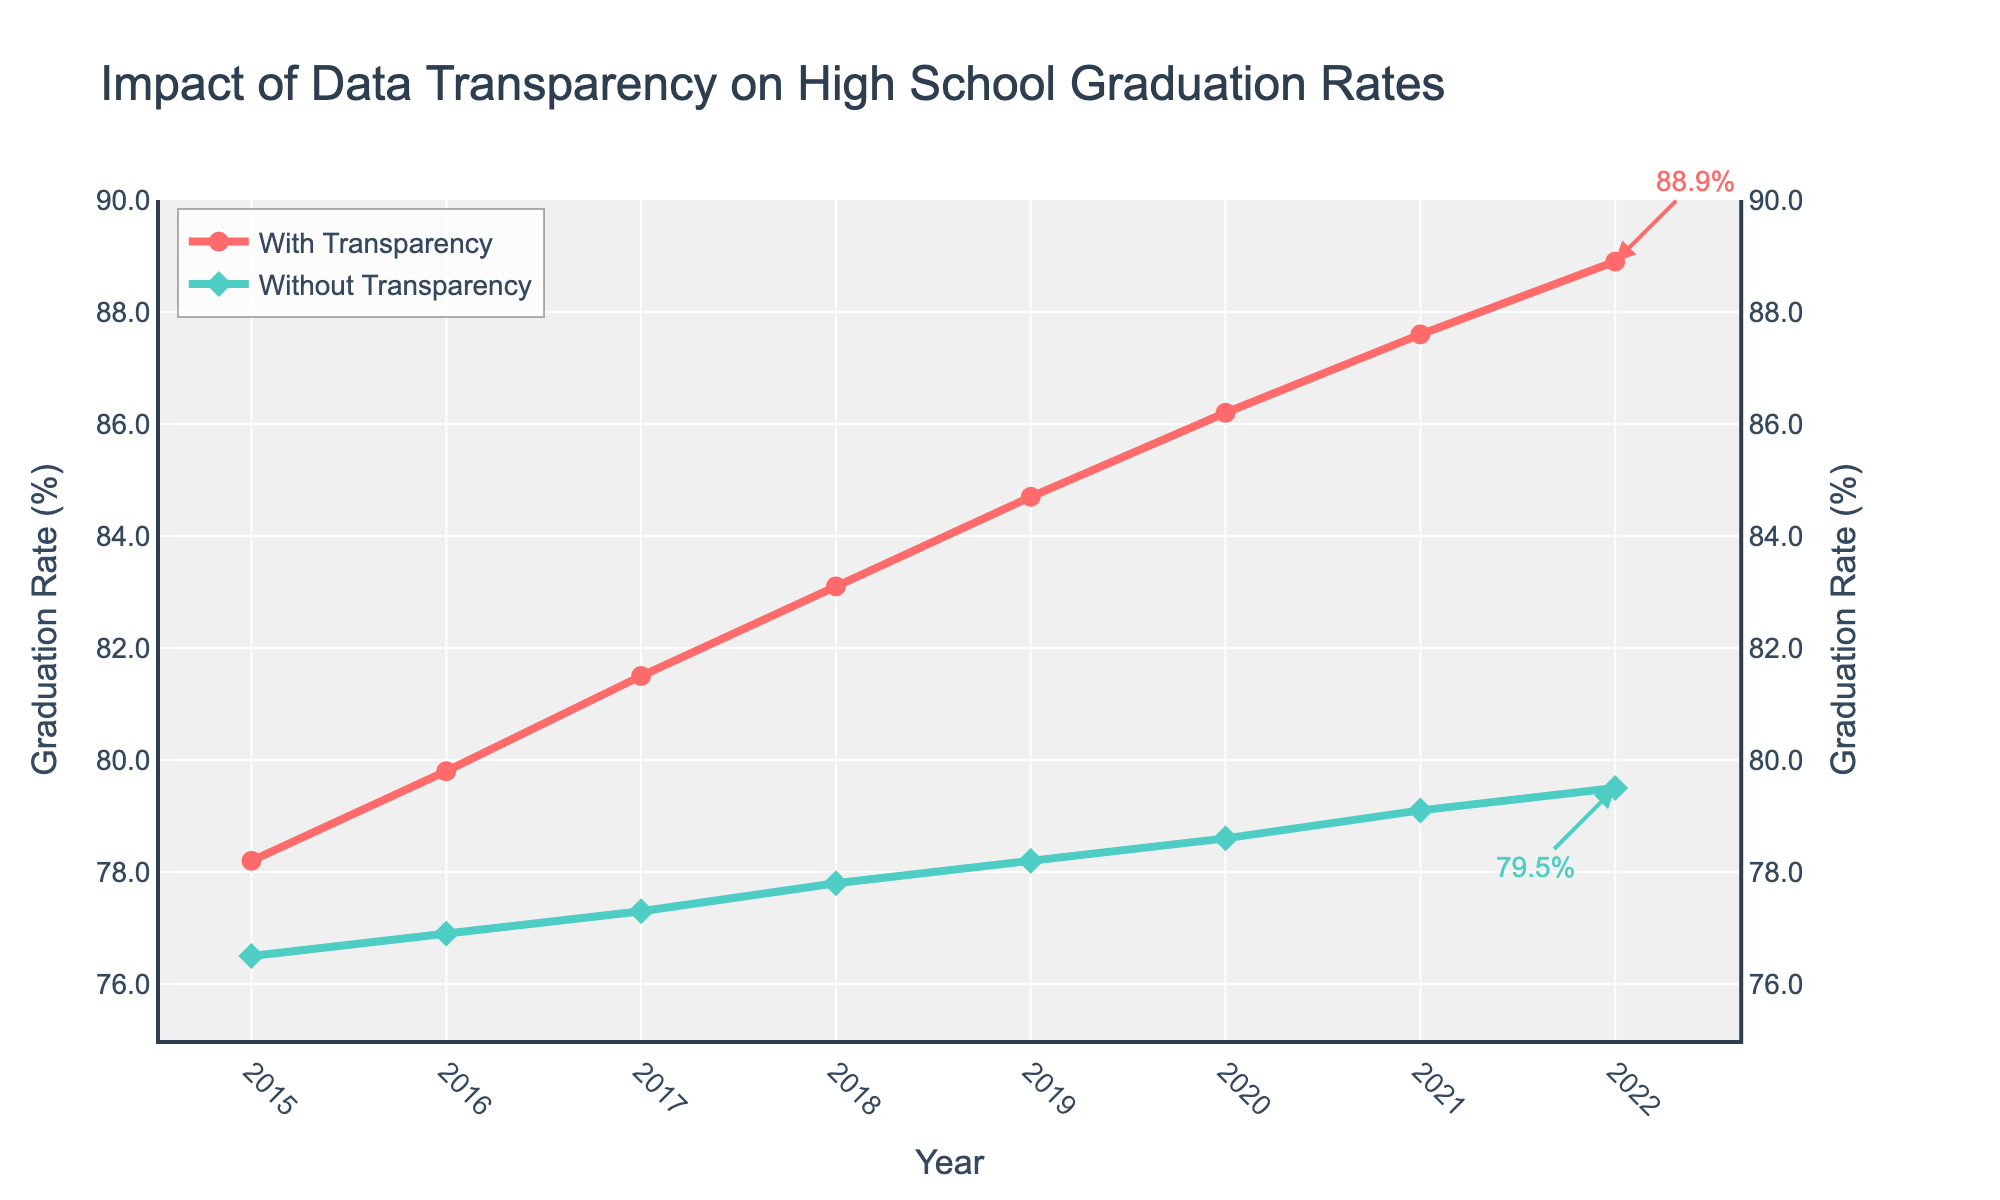What is the graduation rate for schools with transparency initiatives in 2020? The plot shows the graduation rates for each year. Looking at the line for "With Transparency" in 2020, the graduation rate is indicated by the point on the graph.
Answer: 86.2% How much did the graduation rate for schools with transparency initiatives increase from 2015 to 2022? First, find the rates for both years: 78.2% in 2015 and 88.9% in 2022. Subtract the 2015 rate from the 2022 rate: 88.9% - 78.2% = 10.7%.
Answer: 10.7% Which year shows the smallest difference in graduation rates between schools with and without transparency? Compute the differences for each year, then identify the smallest difference. Differences: 1.7, 2.9, 4.2, 5.3, 6.5, 7.6, 8.5, 9.4. The smallest difference is 1.7 in 2015.
Answer: 2015 What is the trend in graduation rates for schools without transparency from 2015 to 2022? Observe the direction of the line marking "Without Transparency." The line shows a gradual upward trend, with rates increasing each year.
Answer: Increasing Which year had the highest graduation rate for schools with transparency initiatives? Look at the date on the x-axis where the peak value for "With Transparency" occurs. The highest point is in 2022.
Answer: 2022 Compare the average graduation rates of schools with and without transparency initiatives over the period 2015-2022. Calculate the averages for each line. Sum the values for 2015 to 2022 and divide by the number of years (8). With Transparency: (78.2 + 79.8 + 81.5 + 83.1 + 84.7 + 86.2 + 87.6 + 88.9) / 8 = 83.75. Without Transparency: (76.5 + 76.9 + 77.3 + 77.8 + 78.2 + 78.6 + 79.1 + 79.5) / 8 = 78.11.
Answer: With Transparency: 83.75, Without Transparency: 78.11 What is the visual difference in the markers used for schools with and without transparency initiatives? The graph uses different shapes and colors for markers: "With Transparency" uses red circles, and "Without Transparency" uses green diamonds.
Answer: Red circles and green diamonds Is the graduation rate for schools without transparency above 78% in 2018? Check the graduation rate for "Without Transparency" in 2018 on the y-axis, which is 77.8%. This is not above 78%.
Answer: No By how much did the graduation rate for schools without transparency increase from 2017 to 2018? Find the rates for both years: 77.3% in 2017 and 77.8% in 2018. Subtract the 2017 rate from the 2018 rate: 77.8% - 77.3% = 0.5%.
Answer: 0.5% 